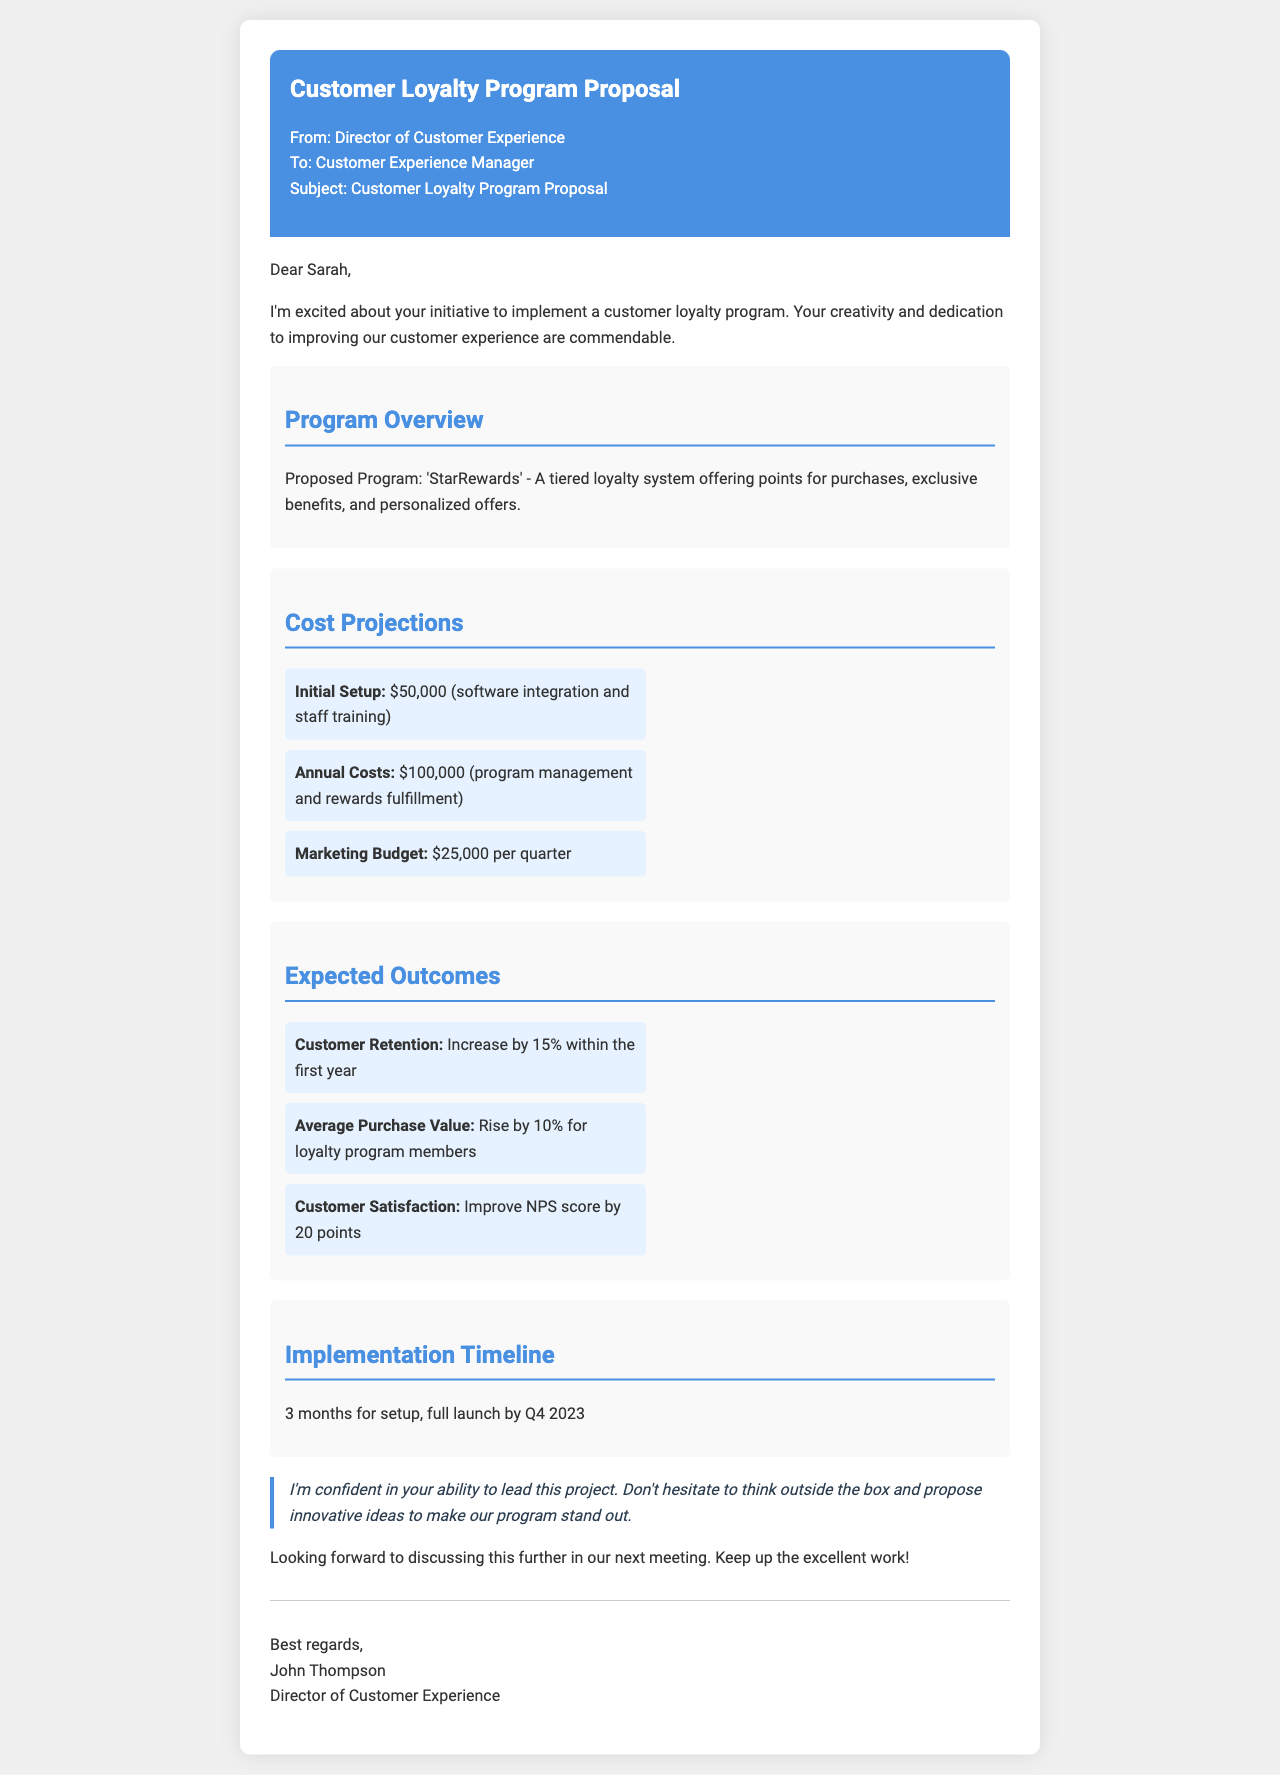What is the name of the proposed program? The proposed program is referred to as 'StarRewards' in the document.
Answer: 'StarRewards' What is the initial setup cost? The initial setup cost is $50,000 as stated in the cost projections section.
Answer: $50,000 What is the expected increase in customer retention? The document states that customer retention is expected to increase by 15% within the first year.
Answer: 15% How long is the implementation timeline? The implementation timeline is mentioned as 3 months for setup.
Answer: 3 months What is the annual cost for program management? The annual costs include $100,000 for program management and rewards fulfillment.
Answer: $100,000 What is the expected rise in average purchase value for loyalty program members? The expected rise in average purchase value is stated to be 10% for loyalty program members.
Answer: 10% Who is the author of the document? The author of the document is identified as John Thompson, the Director of Customer Experience.
Answer: John Thompson What is the marketing budget per quarter? The marketing budget specified in the document is $25,000 per quarter.
Answer: $25,000 What is the expected improvement in the NPS score? The expected improvement in the NPS score is 20 points according to the expected outcomes section.
Answer: 20 points 